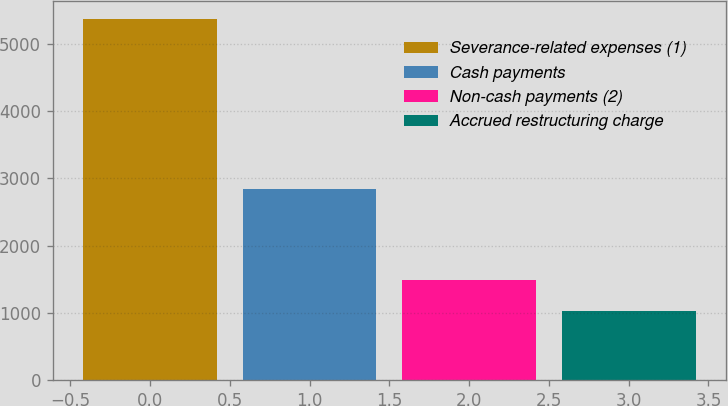Convert chart. <chart><loc_0><loc_0><loc_500><loc_500><bar_chart><fcel>Severance-related expenses (1)<fcel>Cash payments<fcel>Non-cash payments (2)<fcel>Accrued restructuring charge<nl><fcel>5360<fcel>2837<fcel>1488<fcel>1035<nl></chart> 